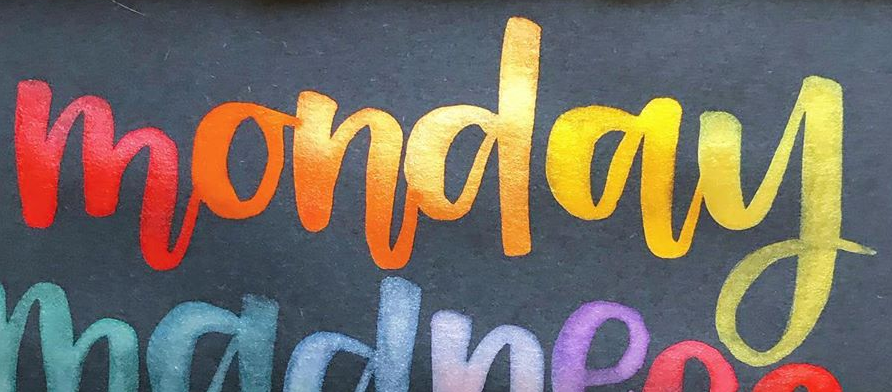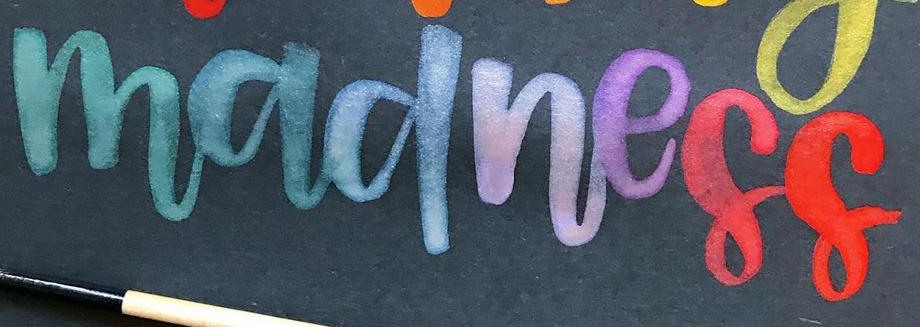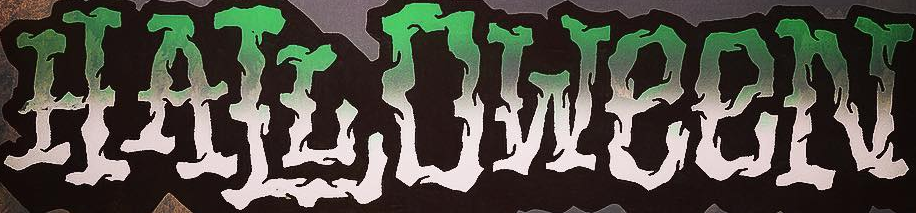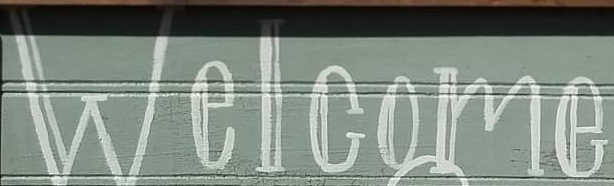What text appears in these images from left to right, separated by a semicolon? monday; madness; HALLOWeeN; Welcome 